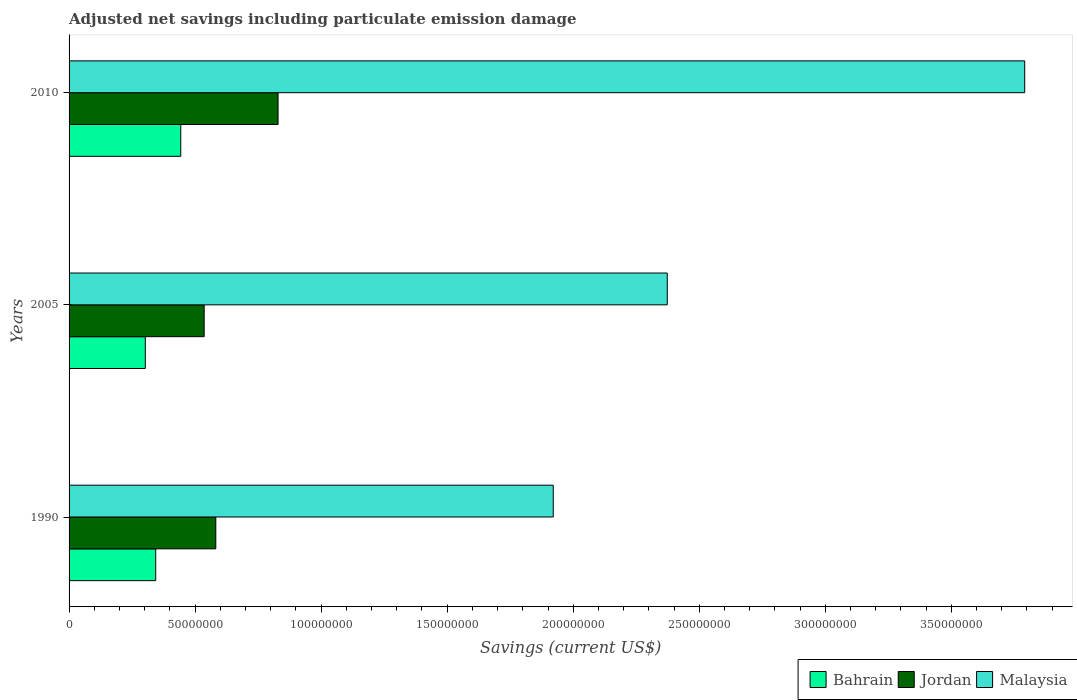How many groups of bars are there?
Offer a terse response. 3. Are the number of bars per tick equal to the number of legend labels?
Your response must be concise. Yes. Are the number of bars on each tick of the Y-axis equal?
Offer a terse response. Yes. How many bars are there on the 2nd tick from the bottom?
Your answer should be very brief. 3. What is the label of the 1st group of bars from the top?
Your answer should be very brief. 2010. In how many cases, is the number of bars for a given year not equal to the number of legend labels?
Make the answer very short. 0. What is the net savings in Malaysia in 2010?
Your answer should be very brief. 3.79e+08. Across all years, what is the maximum net savings in Bahrain?
Offer a very short reply. 4.43e+07. Across all years, what is the minimum net savings in Jordan?
Offer a terse response. 5.36e+07. In which year was the net savings in Jordan maximum?
Ensure brevity in your answer.  2010. What is the total net savings in Malaysia in the graph?
Your answer should be very brief. 8.09e+08. What is the difference between the net savings in Bahrain in 1990 and that in 2010?
Provide a short and direct response. -9.94e+06. What is the difference between the net savings in Jordan in 1990 and the net savings in Malaysia in 2010?
Offer a terse response. -3.21e+08. What is the average net savings in Jordan per year?
Make the answer very short. 6.49e+07. In the year 2010, what is the difference between the net savings in Jordan and net savings in Bahrain?
Provide a short and direct response. 3.86e+07. What is the ratio of the net savings in Malaysia in 2005 to that in 2010?
Provide a succinct answer. 0.63. Is the net savings in Jordan in 1990 less than that in 2010?
Your answer should be compact. Yes. Is the difference between the net savings in Jordan in 2005 and 2010 greater than the difference between the net savings in Bahrain in 2005 and 2010?
Your response must be concise. No. What is the difference between the highest and the second highest net savings in Malaysia?
Provide a short and direct response. 1.42e+08. What is the difference between the highest and the lowest net savings in Malaysia?
Offer a very short reply. 1.87e+08. In how many years, is the net savings in Jordan greater than the average net savings in Jordan taken over all years?
Offer a terse response. 1. Is the sum of the net savings in Jordan in 1990 and 2010 greater than the maximum net savings in Bahrain across all years?
Offer a terse response. Yes. What does the 2nd bar from the top in 2005 represents?
Ensure brevity in your answer.  Jordan. What does the 2nd bar from the bottom in 2010 represents?
Offer a very short reply. Jordan. Are all the bars in the graph horizontal?
Offer a very short reply. Yes. Are the values on the major ticks of X-axis written in scientific E-notation?
Make the answer very short. No. Does the graph contain any zero values?
Ensure brevity in your answer.  No. Does the graph contain grids?
Provide a succinct answer. No. Where does the legend appear in the graph?
Provide a short and direct response. Bottom right. How many legend labels are there?
Your answer should be compact. 3. What is the title of the graph?
Provide a succinct answer. Adjusted net savings including particulate emission damage. Does "Montenegro" appear as one of the legend labels in the graph?
Provide a short and direct response. No. What is the label or title of the X-axis?
Provide a succinct answer. Savings (current US$). What is the label or title of the Y-axis?
Offer a terse response. Years. What is the Savings (current US$) of Bahrain in 1990?
Provide a succinct answer. 3.44e+07. What is the Savings (current US$) of Jordan in 1990?
Offer a very short reply. 5.82e+07. What is the Savings (current US$) of Malaysia in 1990?
Provide a succinct answer. 1.92e+08. What is the Savings (current US$) of Bahrain in 2005?
Your response must be concise. 3.02e+07. What is the Savings (current US$) in Jordan in 2005?
Your answer should be very brief. 5.36e+07. What is the Savings (current US$) in Malaysia in 2005?
Your answer should be compact. 2.37e+08. What is the Savings (current US$) in Bahrain in 2010?
Your response must be concise. 4.43e+07. What is the Savings (current US$) of Jordan in 2010?
Ensure brevity in your answer.  8.29e+07. What is the Savings (current US$) in Malaysia in 2010?
Provide a succinct answer. 3.79e+08. Across all years, what is the maximum Savings (current US$) of Bahrain?
Ensure brevity in your answer.  4.43e+07. Across all years, what is the maximum Savings (current US$) of Jordan?
Provide a short and direct response. 8.29e+07. Across all years, what is the maximum Savings (current US$) of Malaysia?
Ensure brevity in your answer.  3.79e+08. Across all years, what is the minimum Savings (current US$) in Bahrain?
Make the answer very short. 3.02e+07. Across all years, what is the minimum Savings (current US$) in Jordan?
Provide a succinct answer. 5.36e+07. Across all years, what is the minimum Savings (current US$) of Malaysia?
Ensure brevity in your answer.  1.92e+08. What is the total Savings (current US$) in Bahrain in the graph?
Keep it short and to the point. 1.09e+08. What is the total Savings (current US$) of Jordan in the graph?
Offer a very short reply. 1.95e+08. What is the total Savings (current US$) in Malaysia in the graph?
Offer a very short reply. 8.09e+08. What is the difference between the Savings (current US$) in Bahrain in 1990 and that in 2005?
Your answer should be compact. 4.13e+06. What is the difference between the Savings (current US$) in Jordan in 1990 and that in 2005?
Provide a succinct answer. 4.62e+06. What is the difference between the Savings (current US$) in Malaysia in 1990 and that in 2005?
Keep it short and to the point. -4.52e+07. What is the difference between the Savings (current US$) in Bahrain in 1990 and that in 2010?
Offer a very short reply. -9.94e+06. What is the difference between the Savings (current US$) in Jordan in 1990 and that in 2010?
Provide a succinct answer. -2.47e+07. What is the difference between the Savings (current US$) in Malaysia in 1990 and that in 2010?
Give a very brief answer. -1.87e+08. What is the difference between the Savings (current US$) of Bahrain in 2005 and that in 2010?
Provide a short and direct response. -1.41e+07. What is the difference between the Savings (current US$) of Jordan in 2005 and that in 2010?
Keep it short and to the point. -2.93e+07. What is the difference between the Savings (current US$) of Malaysia in 2005 and that in 2010?
Give a very brief answer. -1.42e+08. What is the difference between the Savings (current US$) in Bahrain in 1990 and the Savings (current US$) in Jordan in 2005?
Keep it short and to the point. -1.92e+07. What is the difference between the Savings (current US$) of Bahrain in 1990 and the Savings (current US$) of Malaysia in 2005?
Make the answer very short. -2.03e+08. What is the difference between the Savings (current US$) of Jordan in 1990 and the Savings (current US$) of Malaysia in 2005?
Provide a succinct answer. -1.79e+08. What is the difference between the Savings (current US$) of Bahrain in 1990 and the Savings (current US$) of Jordan in 2010?
Your answer should be very brief. -4.85e+07. What is the difference between the Savings (current US$) in Bahrain in 1990 and the Savings (current US$) in Malaysia in 2010?
Offer a terse response. -3.45e+08. What is the difference between the Savings (current US$) in Jordan in 1990 and the Savings (current US$) in Malaysia in 2010?
Offer a terse response. -3.21e+08. What is the difference between the Savings (current US$) in Bahrain in 2005 and the Savings (current US$) in Jordan in 2010?
Make the answer very short. -5.27e+07. What is the difference between the Savings (current US$) in Bahrain in 2005 and the Savings (current US$) in Malaysia in 2010?
Your answer should be very brief. -3.49e+08. What is the difference between the Savings (current US$) in Jordan in 2005 and the Savings (current US$) in Malaysia in 2010?
Your answer should be compact. -3.26e+08. What is the average Savings (current US$) in Bahrain per year?
Your answer should be compact. 3.63e+07. What is the average Savings (current US$) in Jordan per year?
Provide a short and direct response. 6.49e+07. What is the average Savings (current US$) of Malaysia per year?
Keep it short and to the point. 2.70e+08. In the year 1990, what is the difference between the Savings (current US$) of Bahrain and Savings (current US$) of Jordan?
Ensure brevity in your answer.  -2.38e+07. In the year 1990, what is the difference between the Savings (current US$) of Bahrain and Savings (current US$) of Malaysia?
Give a very brief answer. -1.58e+08. In the year 1990, what is the difference between the Savings (current US$) of Jordan and Savings (current US$) of Malaysia?
Your response must be concise. -1.34e+08. In the year 2005, what is the difference between the Savings (current US$) of Bahrain and Savings (current US$) of Jordan?
Provide a succinct answer. -2.34e+07. In the year 2005, what is the difference between the Savings (current US$) in Bahrain and Savings (current US$) in Malaysia?
Keep it short and to the point. -2.07e+08. In the year 2005, what is the difference between the Savings (current US$) of Jordan and Savings (current US$) of Malaysia?
Your answer should be compact. -1.84e+08. In the year 2010, what is the difference between the Savings (current US$) of Bahrain and Savings (current US$) of Jordan?
Provide a short and direct response. -3.86e+07. In the year 2010, what is the difference between the Savings (current US$) in Bahrain and Savings (current US$) in Malaysia?
Your answer should be very brief. -3.35e+08. In the year 2010, what is the difference between the Savings (current US$) of Jordan and Savings (current US$) of Malaysia?
Provide a short and direct response. -2.96e+08. What is the ratio of the Savings (current US$) of Bahrain in 1990 to that in 2005?
Your answer should be compact. 1.14. What is the ratio of the Savings (current US$) of Jordan in 1990 to that in 2005?
Give a very brief answer. 1.09. What is the ratio of the Savings (current US$) in Malaysia in 1990 to that in 2005?
Your answer should be compact. 0.81. What is the ratio of the Savings (current US$) of Bahrain in 1990 to that in 2010?
Ensure brevity in your answer.  0.78. What is the ratio of the Savings (current US$) in Jordan in 1990 to that in 2010?
Offer a very short reply. 0.7. What is the ratio of the Savings (current US$) of Malaysia in 1990 to that in 2010?
Give a very brief answer. 0.51. What is the ratio of the Savings (current US$) in Bahrain in 2005 to that in 2010?
Make the answer very short. 0.68. What is the ratio of the Savings (current US$) in Jordan in 2005 to that in 2010?
Keep it short and to the point. 0.65. What is the ratio of the Savings (current US$) of Malaysia in 2005 to that in 2010?
Provide a short and direct response. 0.63. What is the difference between the highest and the second highest Savings (current US$) in Bahrain?
Provide a short and direct response. 9.94e+06. What is the difference between the highest and the second highest Savings (current US$) in Jordan?
Offer a terse response. 2.47e+07. What is the difference between the highest and the second highest Savings (current US$) of Malaysia?
Offer a terse response. 1.42e+08. What is the difference between the highest and the lowest Savings (current US$) in Bahrain?
Give a very brief answer. 1.41e+07. What is the difference between the highest and the lowest Savings (current US$) of Jordan?
Give a very brief answer. 2.93e+07. What is the difference between the highest and the lowest Savings (current US$) in Malaysia?
Offer a very short reply. 1.87e+08. 